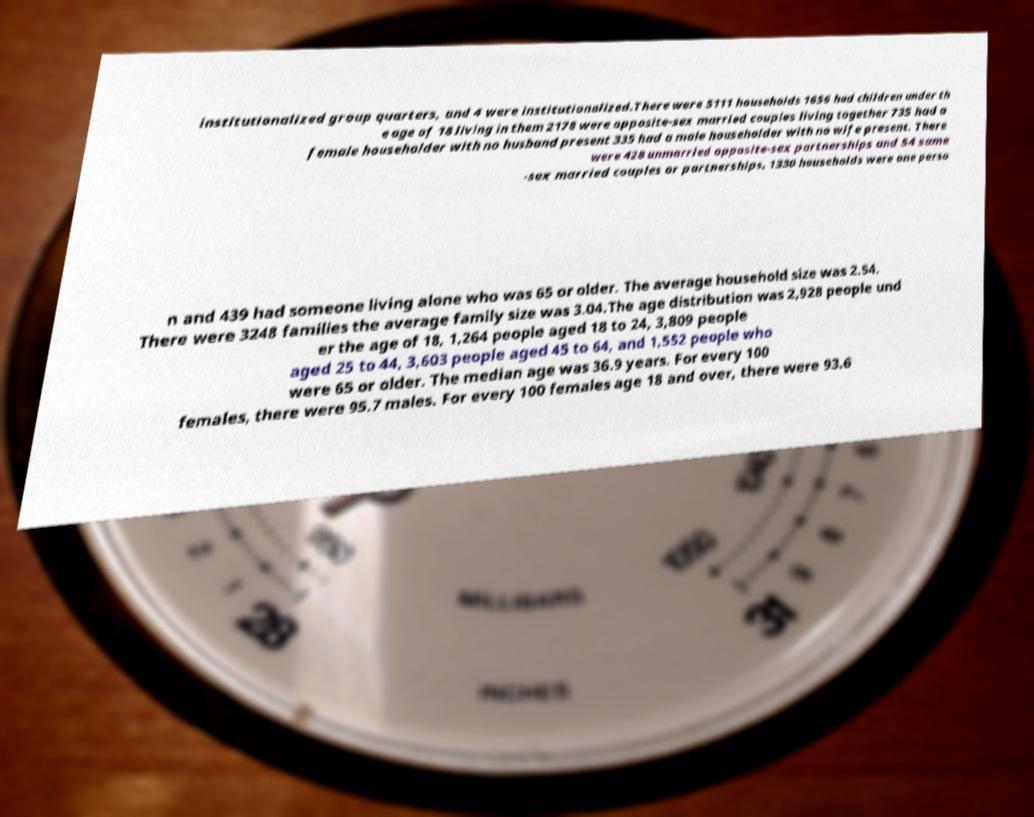Could you assist in decoding the text presented in this image and type it out clearly? institutionalized group quarters, and 4 were institutionalized.There were 5111 households 1656 had children under th e age of 18 living in them 2178 were opposite-sex married couples living together 735 had a female householder with no husband present 335 had a male householder with no wife present. There were 428 unmarried opposite-sex partnerships and 54 same -sex married couples or partnerships. 1330 households were one perso n and 439 had someone living alone who was 65 or older. The average household size was 2.54. There were 3248 families the average family size was 3.04.The age distribution was 2,928 people und er the age of 18, 1,264 people aged 18 to 24, 3,809 people aged 25 to 44, 3,603 people aged 45 to 64, and 1,552 people who were 65 or older. The median age was 36.9 years. For every 100 females, there were 95.7 males. For every 100 females age 18 and over, there were 93.6 